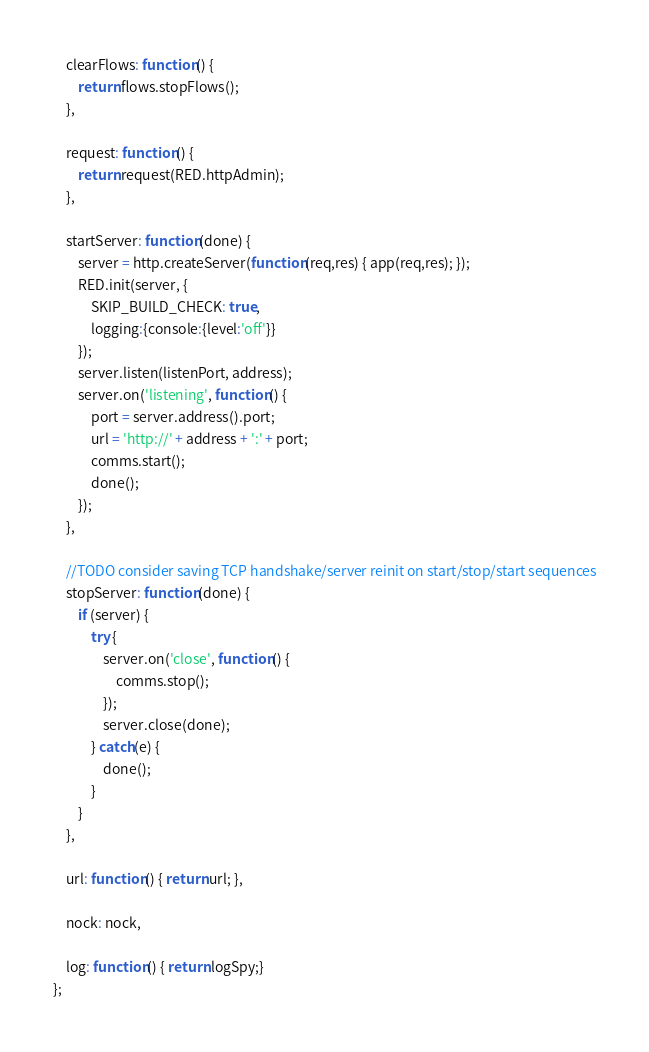<code> <loc_0><loc_0><loc_500><loc_500><_JavaScript_>
    clearFlows: function() {
        return flows.stopFlows();
    },

    request: function() {
        return request(RED.httpAdmin);
    },

    startServer: function(done) {
        server = http.createServer(function(req,res) { app(req,res); });
        RED.init(server, {
            SKIP_BUILD_CHECK: true,
            logging:{console:{level:'off'}}
        });
        server.listen(listenPort, address);
        server.on('listening', function() {
            port = server.address().port;
            url = 'http://' + address + ':' + port;
            comms.start();
            done();
        });
    },

    //TODO consider saving TCP handshake/server reinit on start/stop/start sequences
    stopServer: function(done) {
        if (server) {
            try {
                server.on('close', function() {
                    comms.stop();
                });
                server.close(done);
            } catch(e) {
                done();
            }
        }
    },

    url: function() { return url; },

    nock: nock,

    log: function() { return logSpy;}
};
</code> 